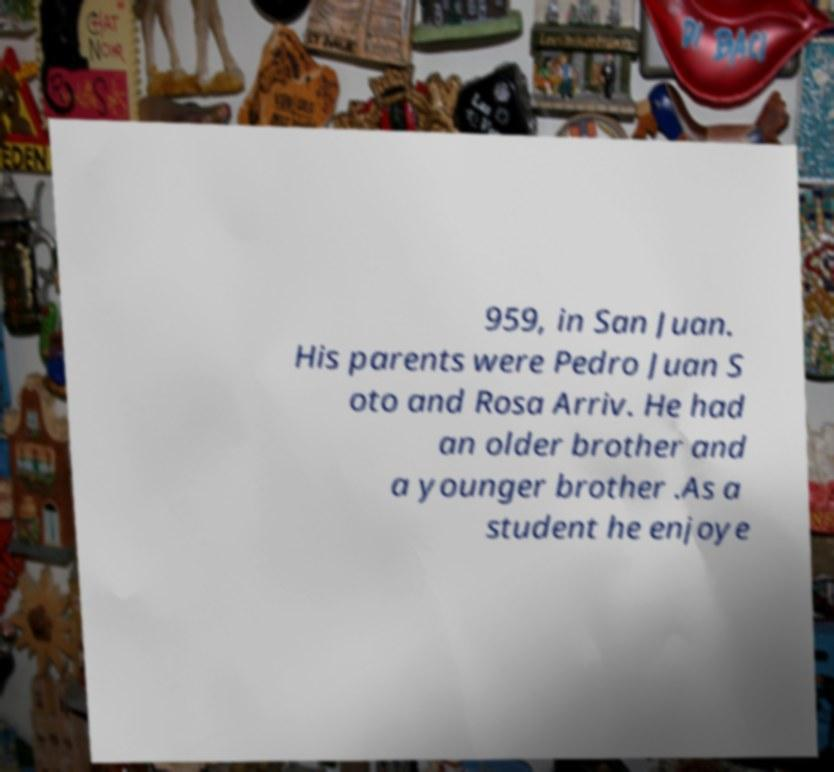I need the written content from this picture converted into text. Can you do that? 959, in San Juan. His parents were Pedro Juan S oto and Rosa Arriv. He had an older brother and a younger brother .As a student he enjoye 